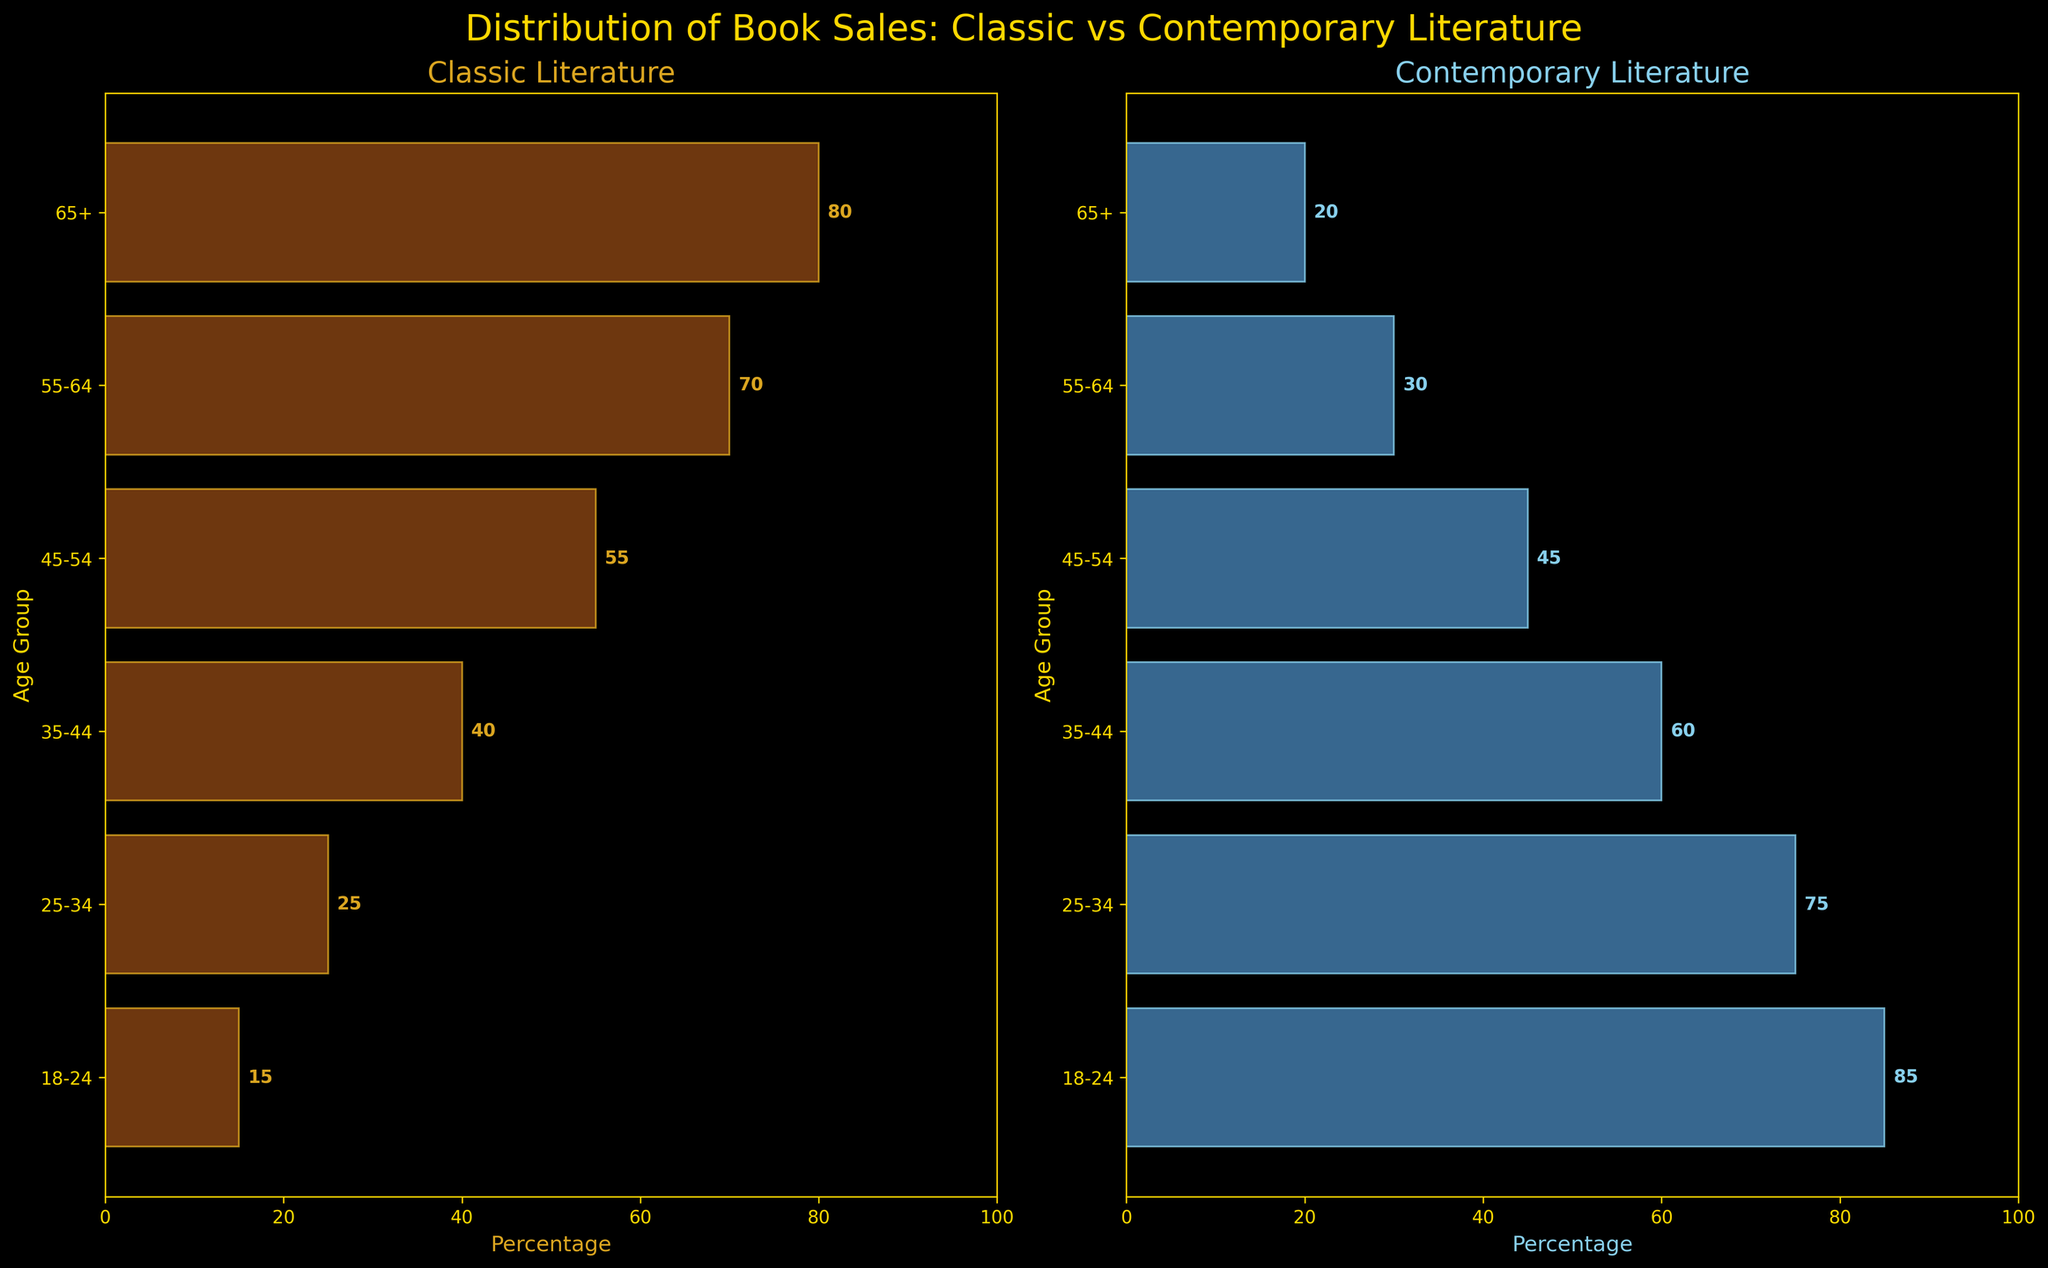What is the title of the figure? The title is displayed at the top center of the figure and reads "Distribution of Book Sales: Classic vs Contemporary Literature" in gold color.
Answer: Distribution of Book Sales: Classic vs Contemporary Literature Which age group shows the highest percentage of classic literature sales? The horizontal bar for the age group 65+ is the longest in the Classic Literature subplot, indicating it has the highest percentage.
Answer: 65+ How does the percentage of contemporary literature in the 18-24 age group compare to the classic literature in the same group? The horizontal bars show that the contemporary literature percentage (85%) is much higher than the classic literature percentage (15%) for the 18-24 age group.
Answer: Contemporary literature (85%) is higher than classic literature (15%) What is the average percentage of classic literature sales across all age groups? Add up the percentages of classic literature sales for all age groups and divide by the number of age groups: (15 + 25 + 40 + 55 + 70 + 80) / 6 = 47.5.
Answer: 47.5% Which age group has the largest difference in percentage between classic and contemporary literature? Calculate the difference for each age group and find the largest: (65+): 80-20=60, (55-64): 70-30=40, (45-54): 55-45=10, etc. The largest difference is for the 65+ group, which is 60.
Answer: 65+ Is the distribution of contemporary literature sales uniform across age groups? Looking at the lengths of the horizontal bars in the Contemporary Literature subplot, the percentages decrease as the age groups increase, indicating the distribution is not uniform but rather skewed towards younger age groups.
Answer: No How many age groups have a higher percentage of classic literature sales than contemporary literature sales? Compare the length of the bars for each age group in both subplots. 3 age groups (35-44, 55-64, and 65+) have a higher percentage of classic literature sales than contemporary literature sales.
Answer: 3 For the age group 45-54, what percentage more classic literature is sold compared to contemporary literature? Calculate the difference between the classic literature percentage (55%) and the contemporary literature percentage (45%) for the 45-54 age group: 55 - 45 = 10%.
Answer: 10% Describe the overall trend in the classic literature sales as age increases. Observe the general direction of the bars in the Classic Literature subplot. As age increases, the percentage of classic literature sales increases consistently across all age groups.
Answer: Increases What is the total percentage of literature sales (both classic and contemporary) for the age group 25-34? Add the percentages of classic and contemporary literature for the 25-34 age group: 25 (classic) + 75 (contemporary) = 100%.
Answer: 100% 